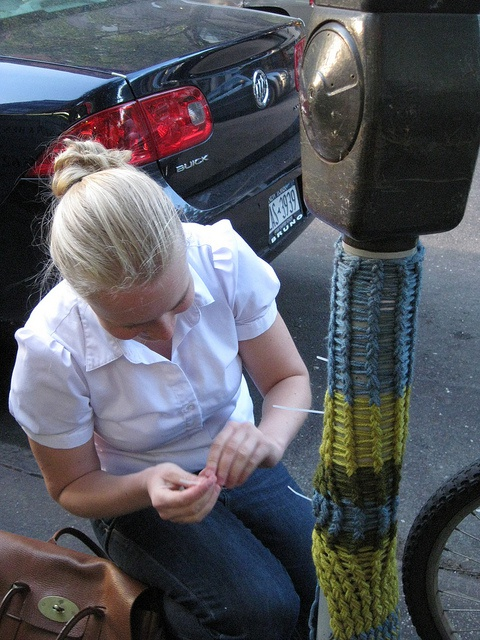Describe the objects in this image and their specific colors. I can see people in teal, black, darkgray, gray, and lavender tones, car in teal, black, gray, and maroon tones, parking meter in teal, black, gray, darkgray, and ivory tones, handbag in teal, black, gray, and maroon tones, and bicycle in teal, black, gray, and darkblue tones in this image. 